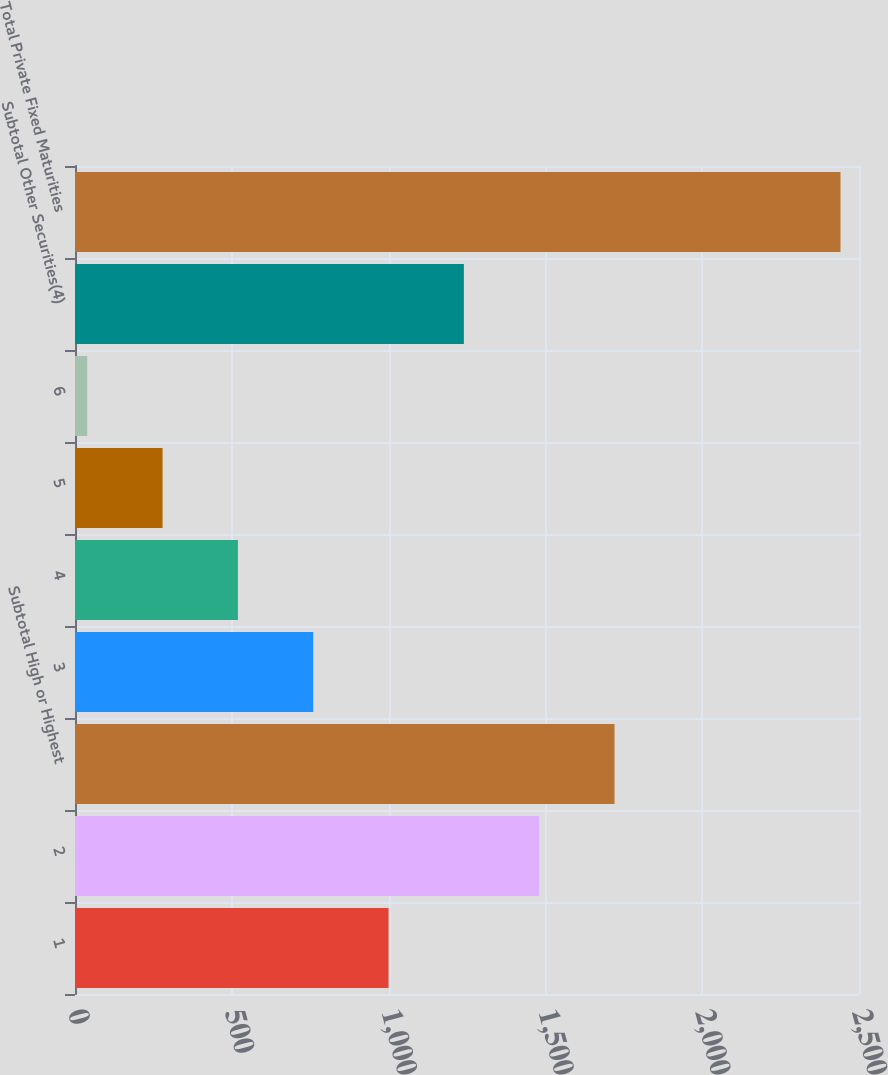Convert chart. <chart><loc_0><loc_0><loc_500><loc_500><bar_chart><fcel>1<fcel>2<fcel>Subtotal High or Highest<fcel>3<fcel>4<fcel>5<fcel>6<fcel>Subtotal Other Securities(4)<fcel>Total Private Fixed Maturities<nl><fcel>999.8<fcel>1480.2<fcel>1720.4<fcel>759.6<fcel>519.4<fcel>279.2<fcel>39<fcel>1240<fcel>2441<nl></chart> 